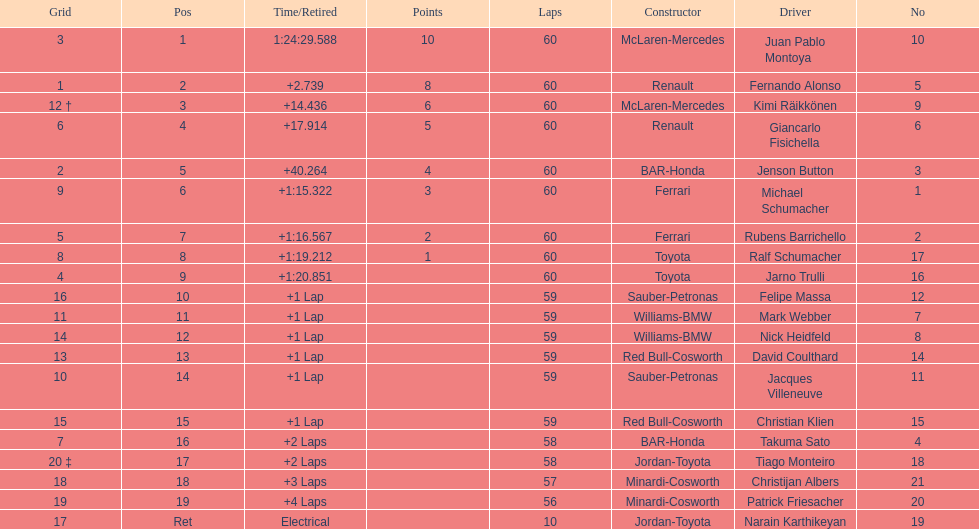Which driver has the least amount of points? Ralf Schumacher. 